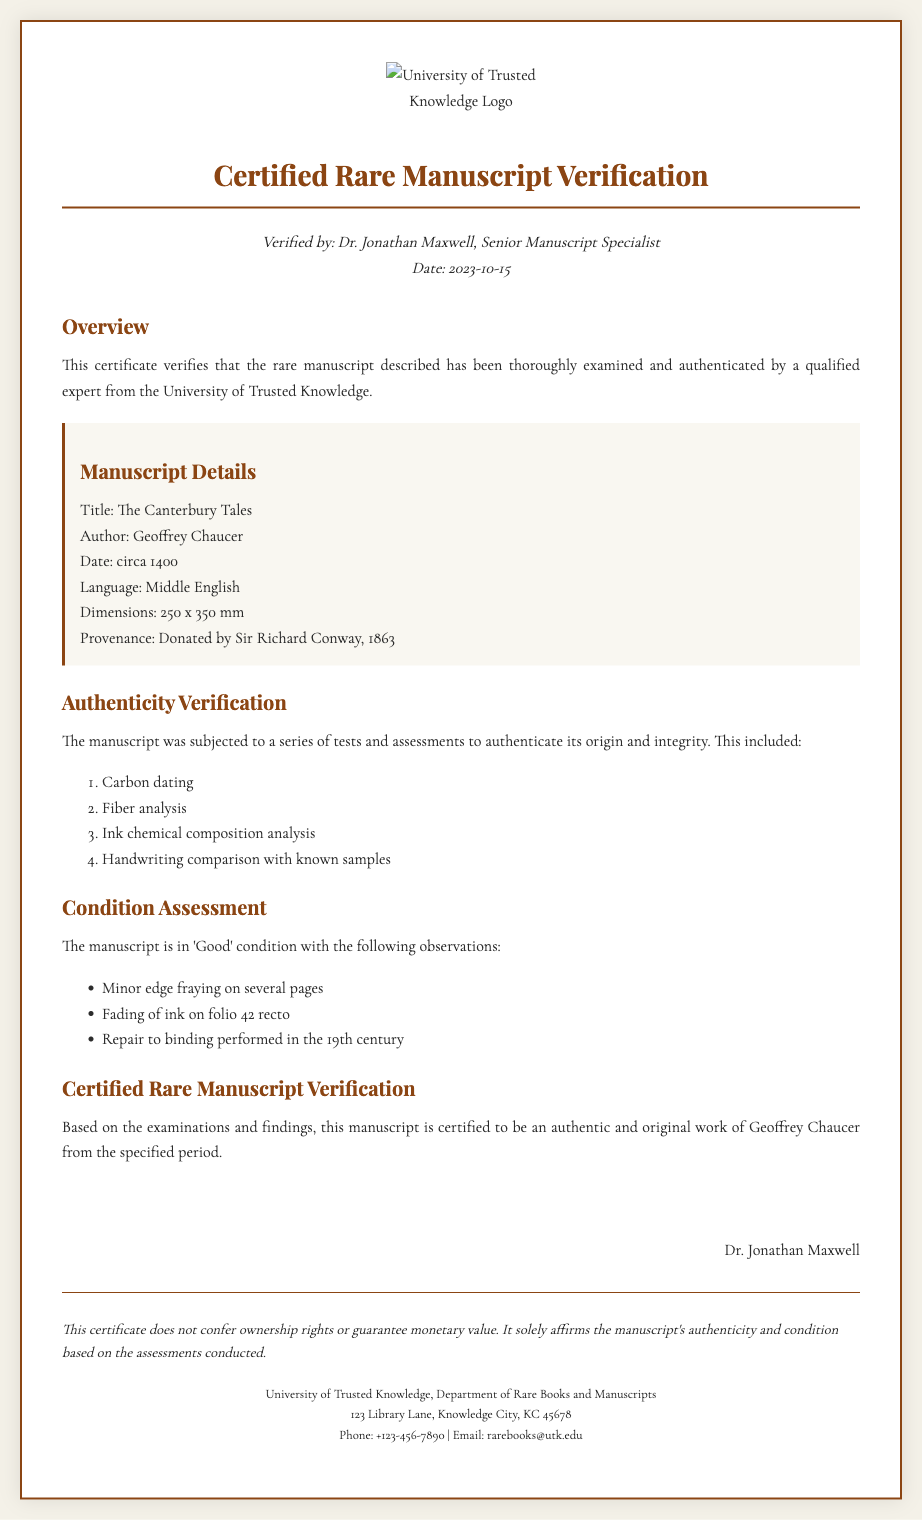What is the title of the manuscript? The title of the manuscript is found in the Manuscript Details section.
Answer: The Canterbury Tales Who is the author of the manuscript? The author's name is listed in the Manuscript Details section.
Answer: Geoffrey Chaucer What date is the manuscript from? The date of the manuscript is explicitly mentioned in the Manuscript Details section.
Answer: circa 1400 Who verified the manuscript? The verifier's name is provided in the header section of the certificate.
Answer: Dr. Jonathan Maxwell What type of analysis was performed for authenticity? The types of analyses performed for authenticity are listed in the Authenticity Verification section.
Answer: Carbon dating What is the condition assessment of the manuscript? The condition of the manuscript is described in the Condition Assessment section.
Answer: Good When was the manuscript donated? The donation date is provided in the Manuscript Details section.
Answer: 1863 What is stated in the disclaimers? The disclaimers provide information about the legal standing of the certificate.
Answer: This certificate does not confer ownership rights What is the contact email for the department? The contact email can be found in the contact section of the certificate.
Answer: rarebooks@utk.edu What are the dimensions of the manuscript? The manuscript's dimensions are specified in the Manuscript Details section.
Answer: 250 x 350 mm 